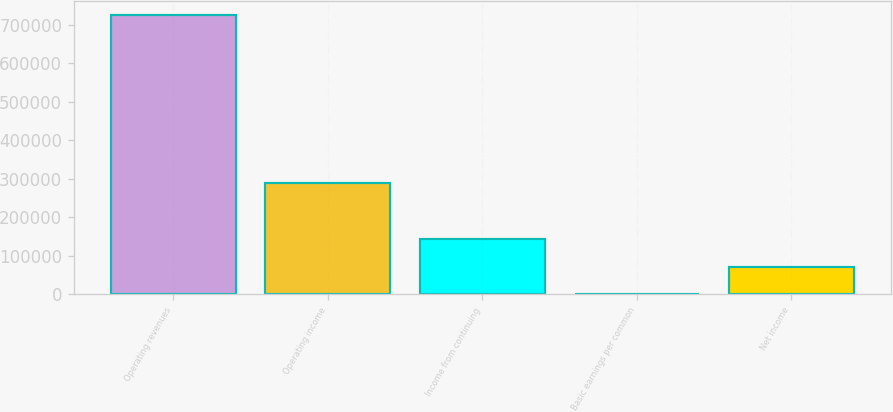Convert chart to OTSL. <chart><loc_0><loc_0><loc_500><loc_500><bar_chart><fcel>Operating revenues<fcel>Operating income<fcel>Income from continuing<fcel>Basic earnings per common<fcel>Net income<nl><fcel>724265<fcel>289706<fcel>144853<fcel>0.57<fcel>72427<nl></chart> 